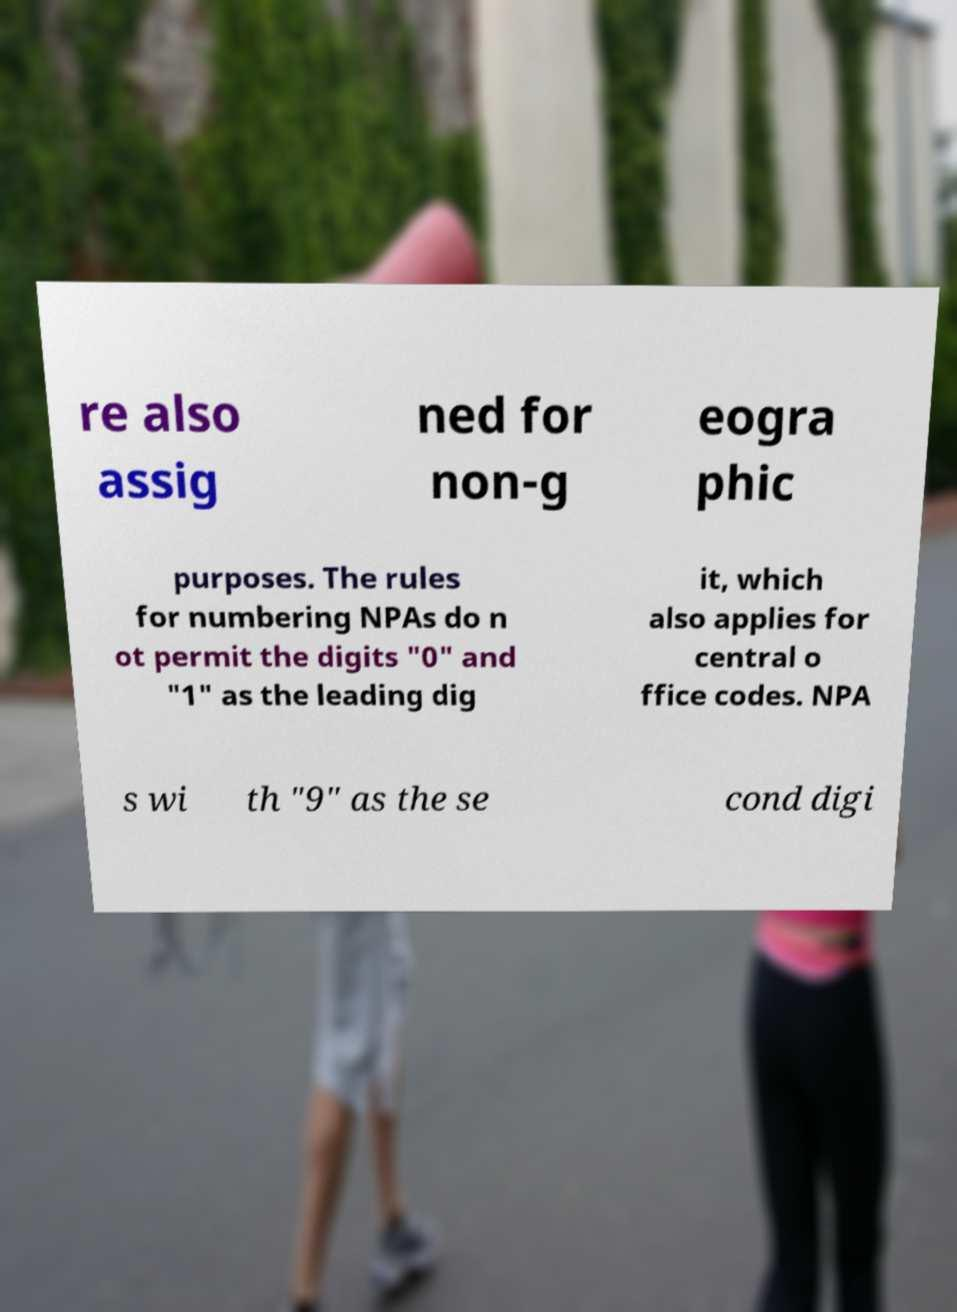For documentation purposes, I need the text within this image transcribed. Could you provide that? re also assig ned for non-g eogra phic purposes. The rules for numbering NPAs do n ot permit the digits "0" and "1" as the leading dig it, which also applies for central o ffice codes. NPA s wi th "9" as the se cond digi 